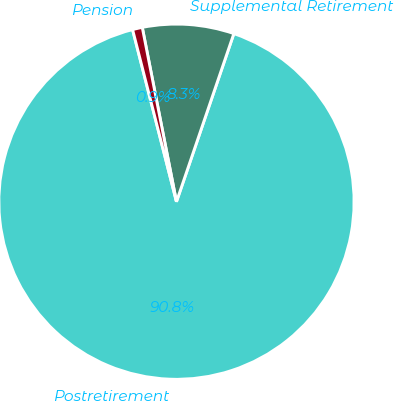Convert chart to OTSL. <chart><loc_0><loc_0><loc_500><loc_500><pie_chart><fcel>Postretirement<fcel>Supplemental Retirement<fcel>Pension<nl><fcel>90.79%<fcel>8.32%<fcel>0.89%<nl></chart> 